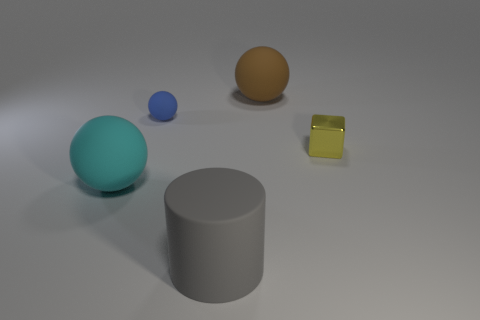Subtract all large brown balls. How many balls are left? 2 Subtract 1 cylinders. How many cylinders are left? 0 Subtract all cyan spheres. How many spheres are left? 2 Add 3 big yellow rubber spheres. How many objects exist? 8 Subtract all gray cylinders. How many blue balls are left? 1 Subtract all brown blocks. Subtract all red spheres. How many blocks are left? 1 Subtract all cylinders. How many objects are left? 4 Add 3 tiny blue rubber objects. How many tiny blue rubber objects are left? 4 Add 1 tiny purple blocks. How many tiny purple blocks exist? 1 Subtract 0 brown cubes. How many objects are left? 5 